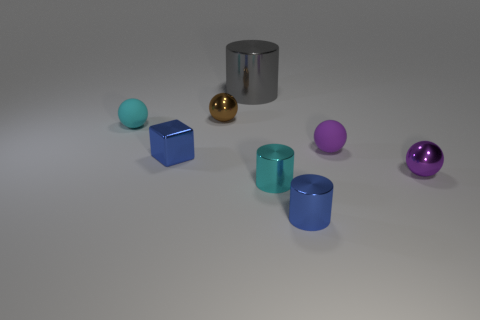How many things are tiny green metal balls or big gray metal objects?
Your response must be concise. 1. What is the shape of the tiny object that is to the left of the purple metallic thing and on the right side of the small blue cylinder?
Provide a succinct answer. Sphere. What number of balls are there?
Your answer should be very brief. 4. There is a cube that is the same material as the big gray cylinder; what is its color?
Provide a succinct answer. Blue. Is the number of tiny brown spheres greater than the number of small cylinders?
Your response must be concise. No. There is a sphere that is in front of the tiny brown sphere and to the left of the large gray metallic object; what is its size?
Your answer should be very brief. Small. There is a tiny object that is the same color as the tiny metal cube; what is its material?
Keep it short and to the point. Metal. Is the number of large objects to the right of the tiny purple matte sphere the same as the number of tiny purple matte spheres?
Your answer should be very brief. No. Does the brown ball have the same size as the blue metal cube?
Your response must be concise. Yes. There is a object that is both to the right of the blue metal cylinder and behind the tiny blue metal cube; what is its color?
Ensure brevity in your answer.  Purple. 